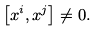Convert formula to latex. <formula><loc_0><loc_0><loc_500><loc_500>\left [ x ^ { i } , x ^ { j } \right ] \neq 0 .</formula> 